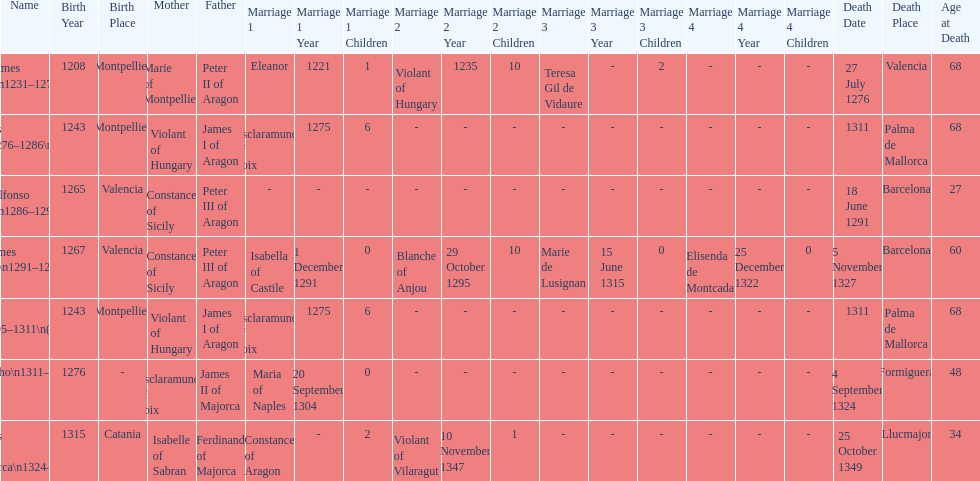Which monarch had the most marriages? James III 1291-1295. 